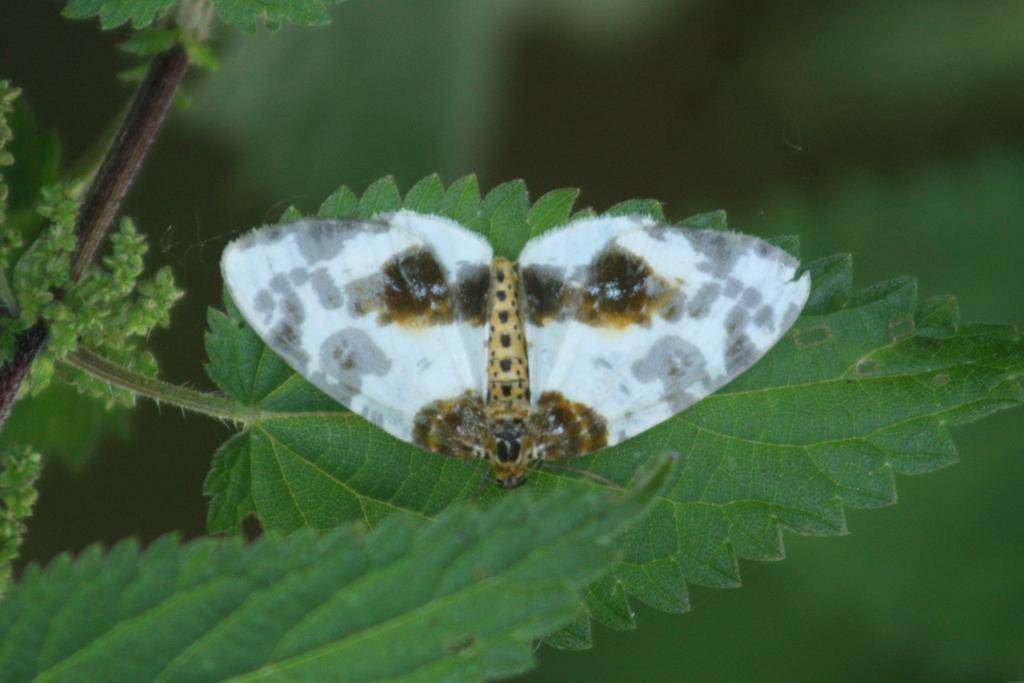What is on the leaf in the image? There is an insect on a leaf in the image. What else can be seen in the image besides the insect? There is a plant in the image. Can you describe the background of the image? The background of the image is blurred. How many balls does the grandfather throw to the brother in the image? There are no balls, grandfathers, or brothers present in the image. 